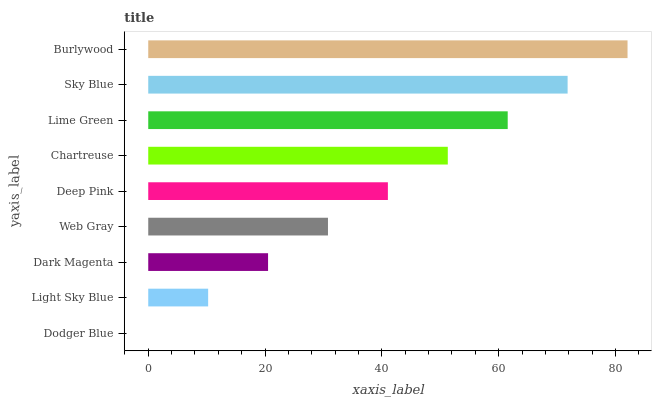Is Dodger Blue the minimum?
Answer yes or no. Yes. Is Burlywood the maximum?
Answer yes or no. Yes. Is Light Sky Blue the minimum?
Answer yes or no. No. Is Light Sky Blue the maximum?
Answer yes or no. No. Is Light Sky Blue greater than Dodger Blue?
Answer yes or no. Yes. Is Dodger Blue less than Light Sky Blue?
Answer yes or no. Yes. Is Dodger Blue greater than Light Sky Blue?
Answer yes or no. No. Is Light Sky Blue less than Dodger Blue?
Answer yes or no. No. Is Deep Pink the high median?
Answer yes or no. Yes. Is Deep Pink the low median?
Answer yes or no. Yes. Is Burlywood the high median?
Answer yes or no. No. Is Dark Magenta the low median?
Answer yes or no. No. 